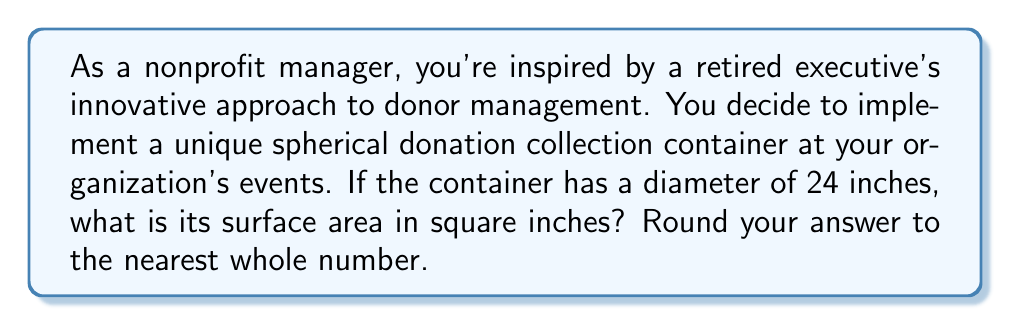Help me with this question. To solve this problem, we'll follow these steps:

1) Recall the formula for the surface area of a sphere:
   $$A = 4\pi r^2$$
   where $A$ is the surface area and $r$ is the radius of the sphere.

2) We're given the diameter of 24 inches. The radius is half of the diameter:
   $$r = \frac{24}{2} = 12\text{ inches}$$

3) Now, let's substitute this into our formula:
   $$A = 4\pi (12)^2$$

4) Simplify:
   $$A = 4\pi (144)$$
   $$A = 576\pi$$

5) Calculate (using $\pi \approx 3.14159$):
   $$A \approx 576 * 3.14159 \approx 1809.56\text{ square inches}$$

6) Rounding to the nearest whole number:
   $$A \approx 1810\text{ square inches}$$

This spherical donation container will have a surface area of approximately 1810 square inches.
Answer: 1810 square inches 